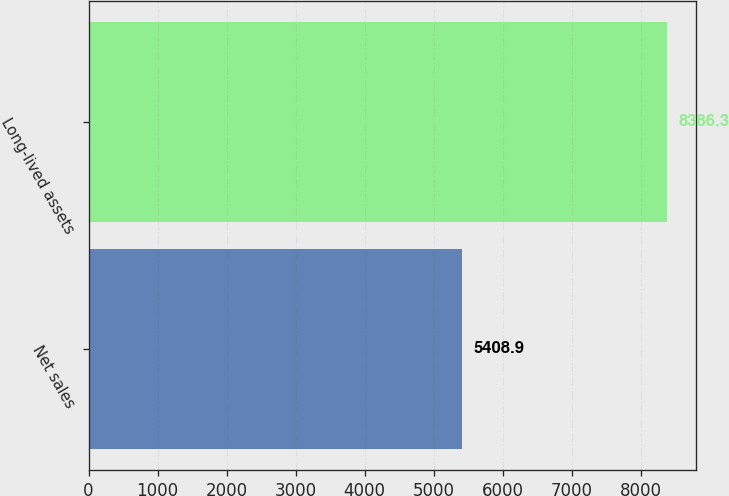Convert chart. <chart><loc_0><loc_0><loc_500><loc_500><bar_chart><fcel>Net sales<fcel>Long-lived assets<nl><fcel>5408.9<fcel>8386.3<nl></chart> 